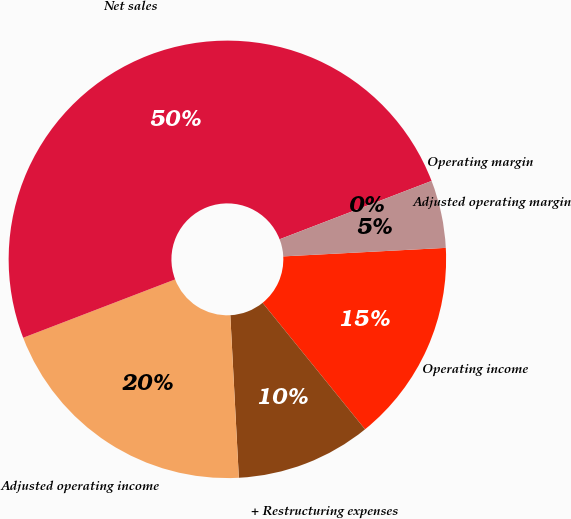Convert chart. <chart><loc_0><loc_0><loc_500><loc_500><pie_chart><fcel>Operating income<fcel>+ Restructuring expenses<fcel>Adjusted operating income<fcel>Net sales<fcel>Operating margin<fcel>Adjusted operating margin<nl><fcel>15.0%<fcel>10.0%<fcel>20.0%<fcel>50.0%<fcel>0.0%<fcel>5.0%<nl></chart> 